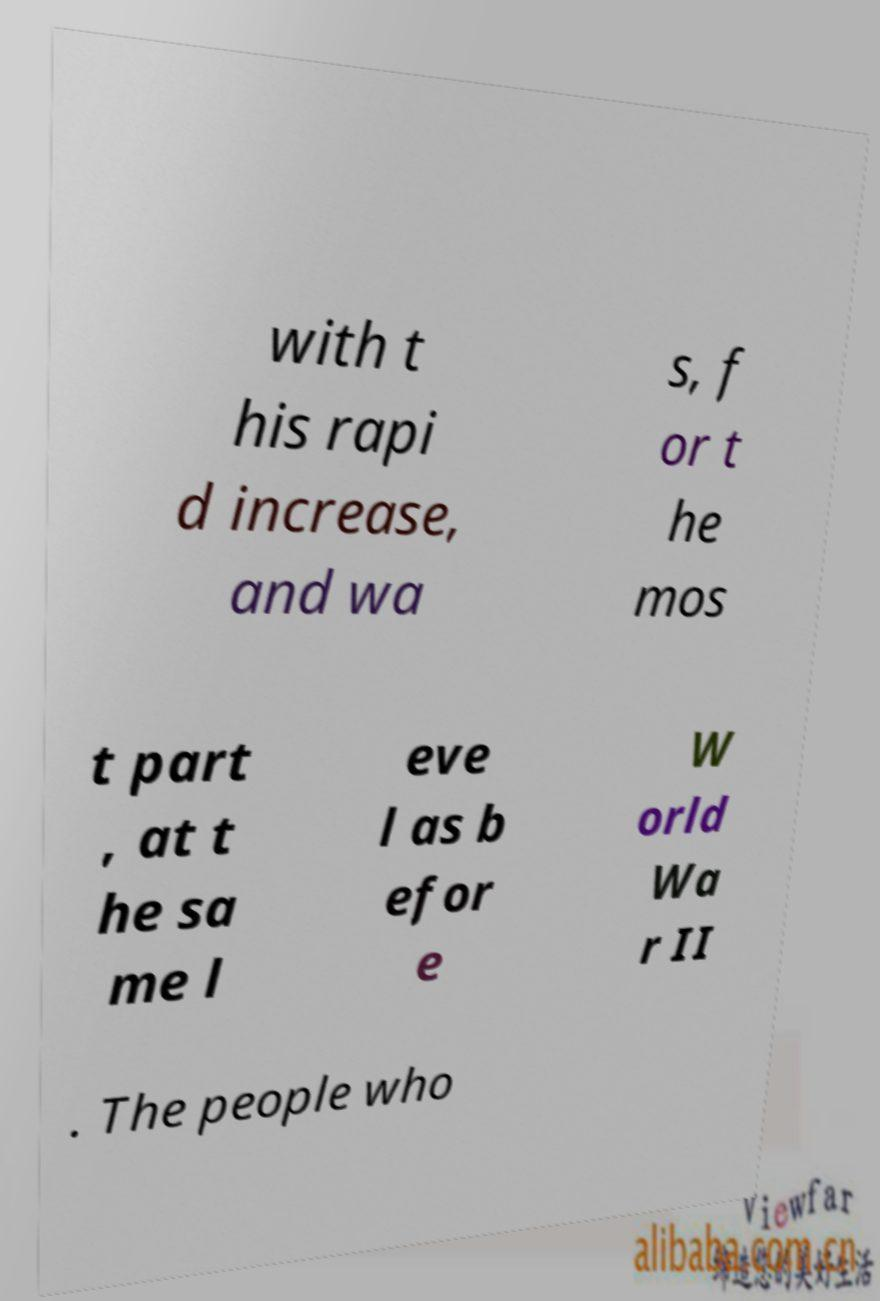Please read and relay the text visible in this image. What does it say? with t his rapi d increase, and wa s, f or t he mos t part , at t he sa me l eve l as b efor e W orld Wa r II . The people who 